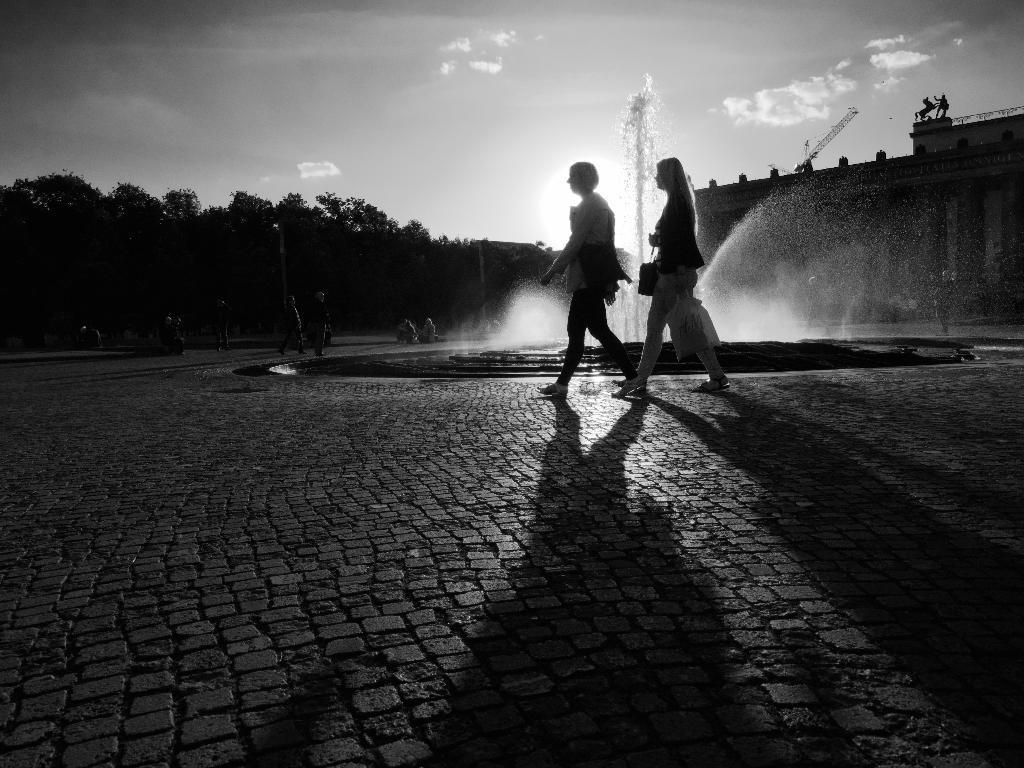How would you summarize this image in a sentence or two? This picture is clicked outside. In center we can see the group of persons seems to be walking on the ground and we can see a fountain and some other objects. In the background we can see the sky, trees, metal rods, buildings and some other objects. 